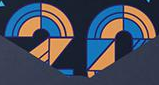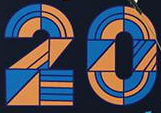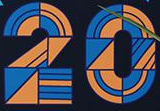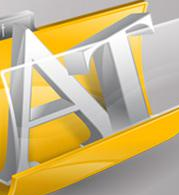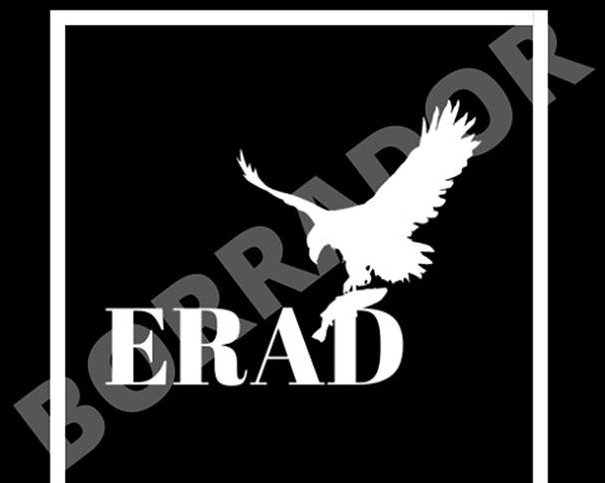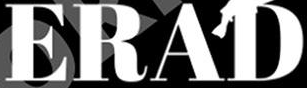Read the text from these images in sequence, separated by a semicolon. 20; 20; 20; AT; BORRADOR; ERAD 